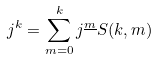Convert formula to latex. <formula><loc_0><loc_0><loc_500><loc_500>j ^ { k } = \sum _ { m = 0 } ^ { k } j ^ { \underline { m } } S ( k , m )</formula> 